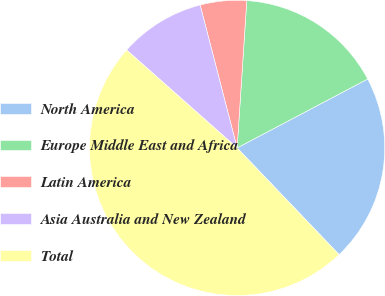<chart> <loc_0><loc_0><loc_500><loc_500><pie_chart><fcel>North America<fcel>Europe Middle East and Africa<fcel>Latin America<fcel>Asia Australia and New Zealand<fcel>Total<nl><fcel>20.59%<fcel>16.23%<fcel>5.07%<fcel>9.43%<fcel>48.68%<nl></chart> 